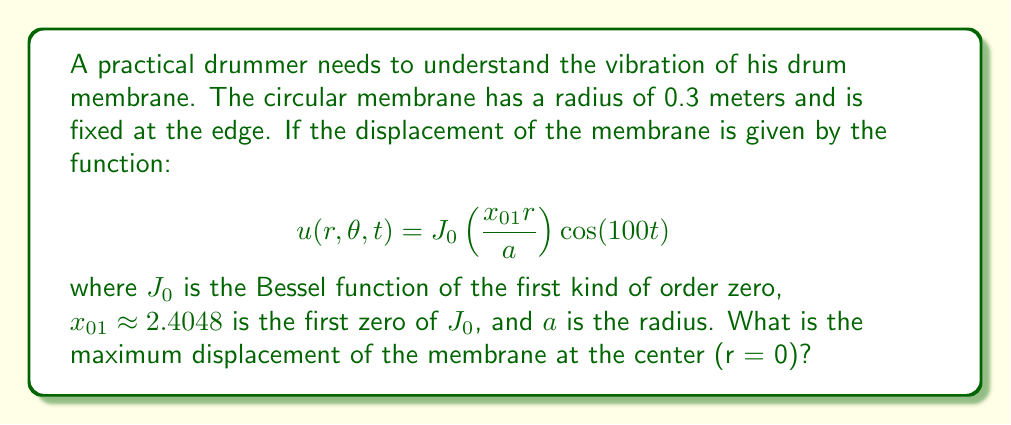Solve this math problem. Let's approach this step-by-step:

1) The displacement function is given as:
   $$u(r,\theta,t) = J_0\left(\frac{x_{01}r}{a}\right)\cos(100t)$$

2) We need to find the maximum displacement at the center, where r = 0.

3) At r = 0, the Bessel function $J_0(0) = 1$. This is a property of Bessel functions.

4) Substituting r = 0 into the displacement function:
   $$u(0,\theta,t) = J_0(0)\cos(100t) = 1 \cdot \cos(100t)$$

5) The cosine function oscillates between -1 and 1. The maximum value occurs when cos(100t) = 1.

6) Therefore, the maximum displacement at the center is 1 unit.
Answer: 1 unit 